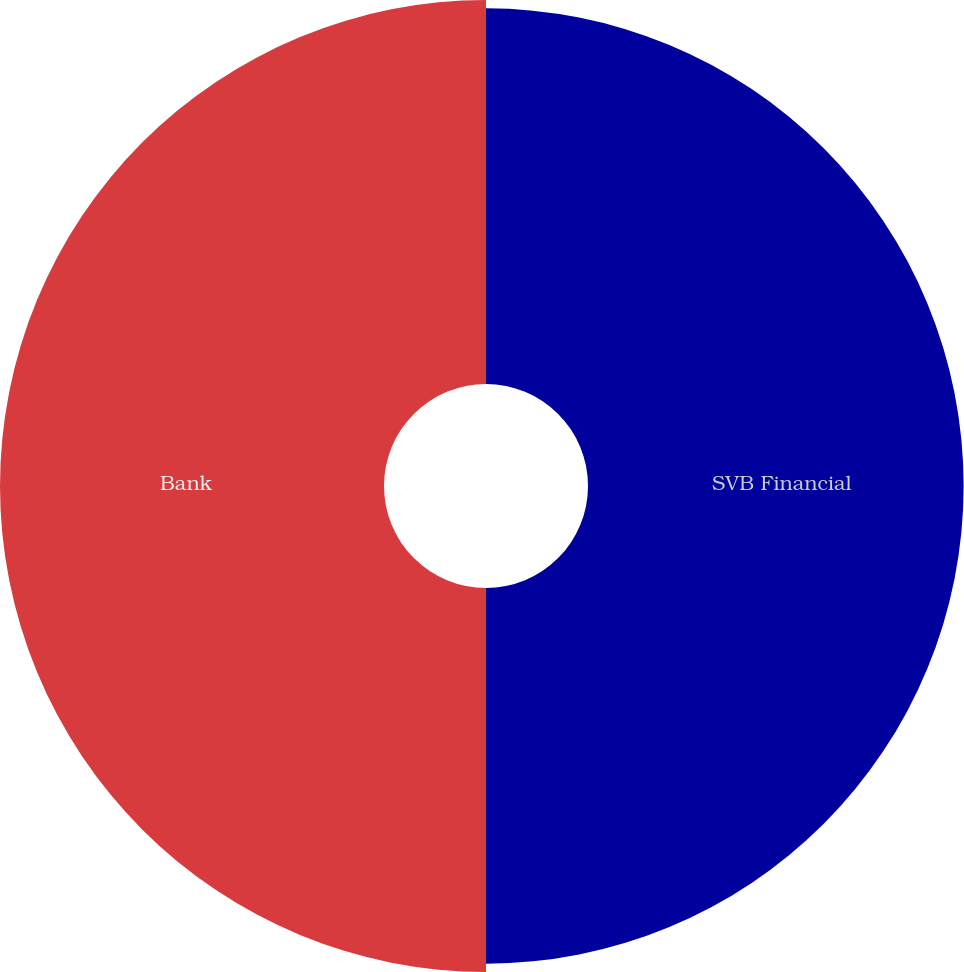Convert chart. <chart><loc_0><loc_0><loc_500><loc_500><pie_chart><fcel>SVB Financial<fcel>Bank<nl><fcel>49.45%<fcel>50.55%<nl></chart> 